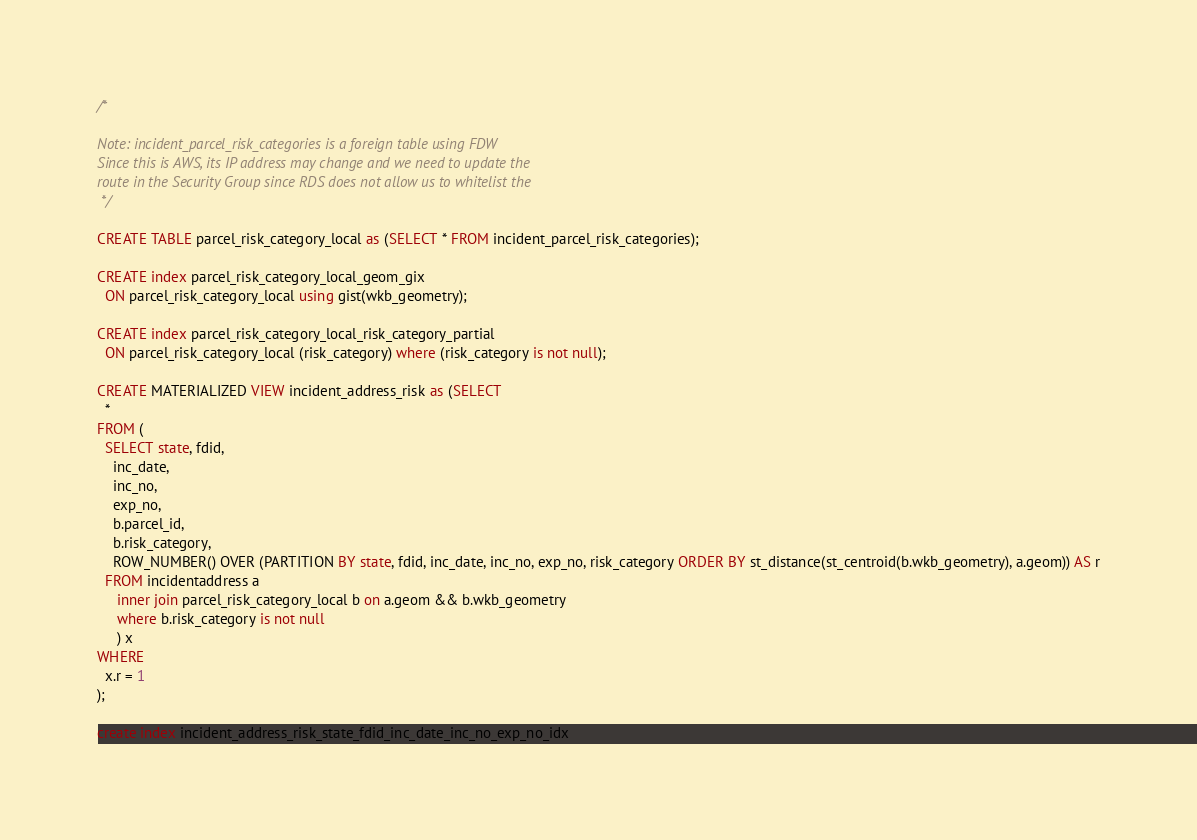Convert code to text. <code><loc_0><loc_0><loc_500><loc_500><_SQL_>/*

Note: incident_parcel_risk_categories is a foreign table using FDW
Since this is AWS, its IP address may change and we need to update the
route in the Security Group since RDS does not allow us to whitelist the
 */

CREATE TABLE parcel_risk_category_local as (SELECT * FROM incident_parcel_risk_categories);

CREATE index parcel_risk_category_local_geom_gix
  ON parcel_risk_category_local using gist(wkb_geometry);

CREATE index parcel_risk_category_local_risk_category_partial
  ON parcel_risk_category_local (risk_category) where (risk_category is not null);

CREATE MATERIALIZED VIEW incident_address_risk as (SELECT
  *
FROM (
  SELECT state, fdid,
    inc_date,
    inc_no,
    exp_no,
    b.parcel_id,
    b.risk_category,
    ROW_NUMBER() OVER (PARTITION BY state, fdid, inc_date, inc_no, exp_no, risk_category ORDER BY st_distance(st_centroid(b.wkb_geometry), a.geom)) AS r
  FROM incidentaddress a
     inner join parcel_risk_category_local b on a.geom && b.wkb_geometry
     where b.risk_category is not null
     ) x
WHERE
  x.r = 1
);

create index incident_address_risk_state_fdid_inc_date_inc_no_exp_no_idx</code> 